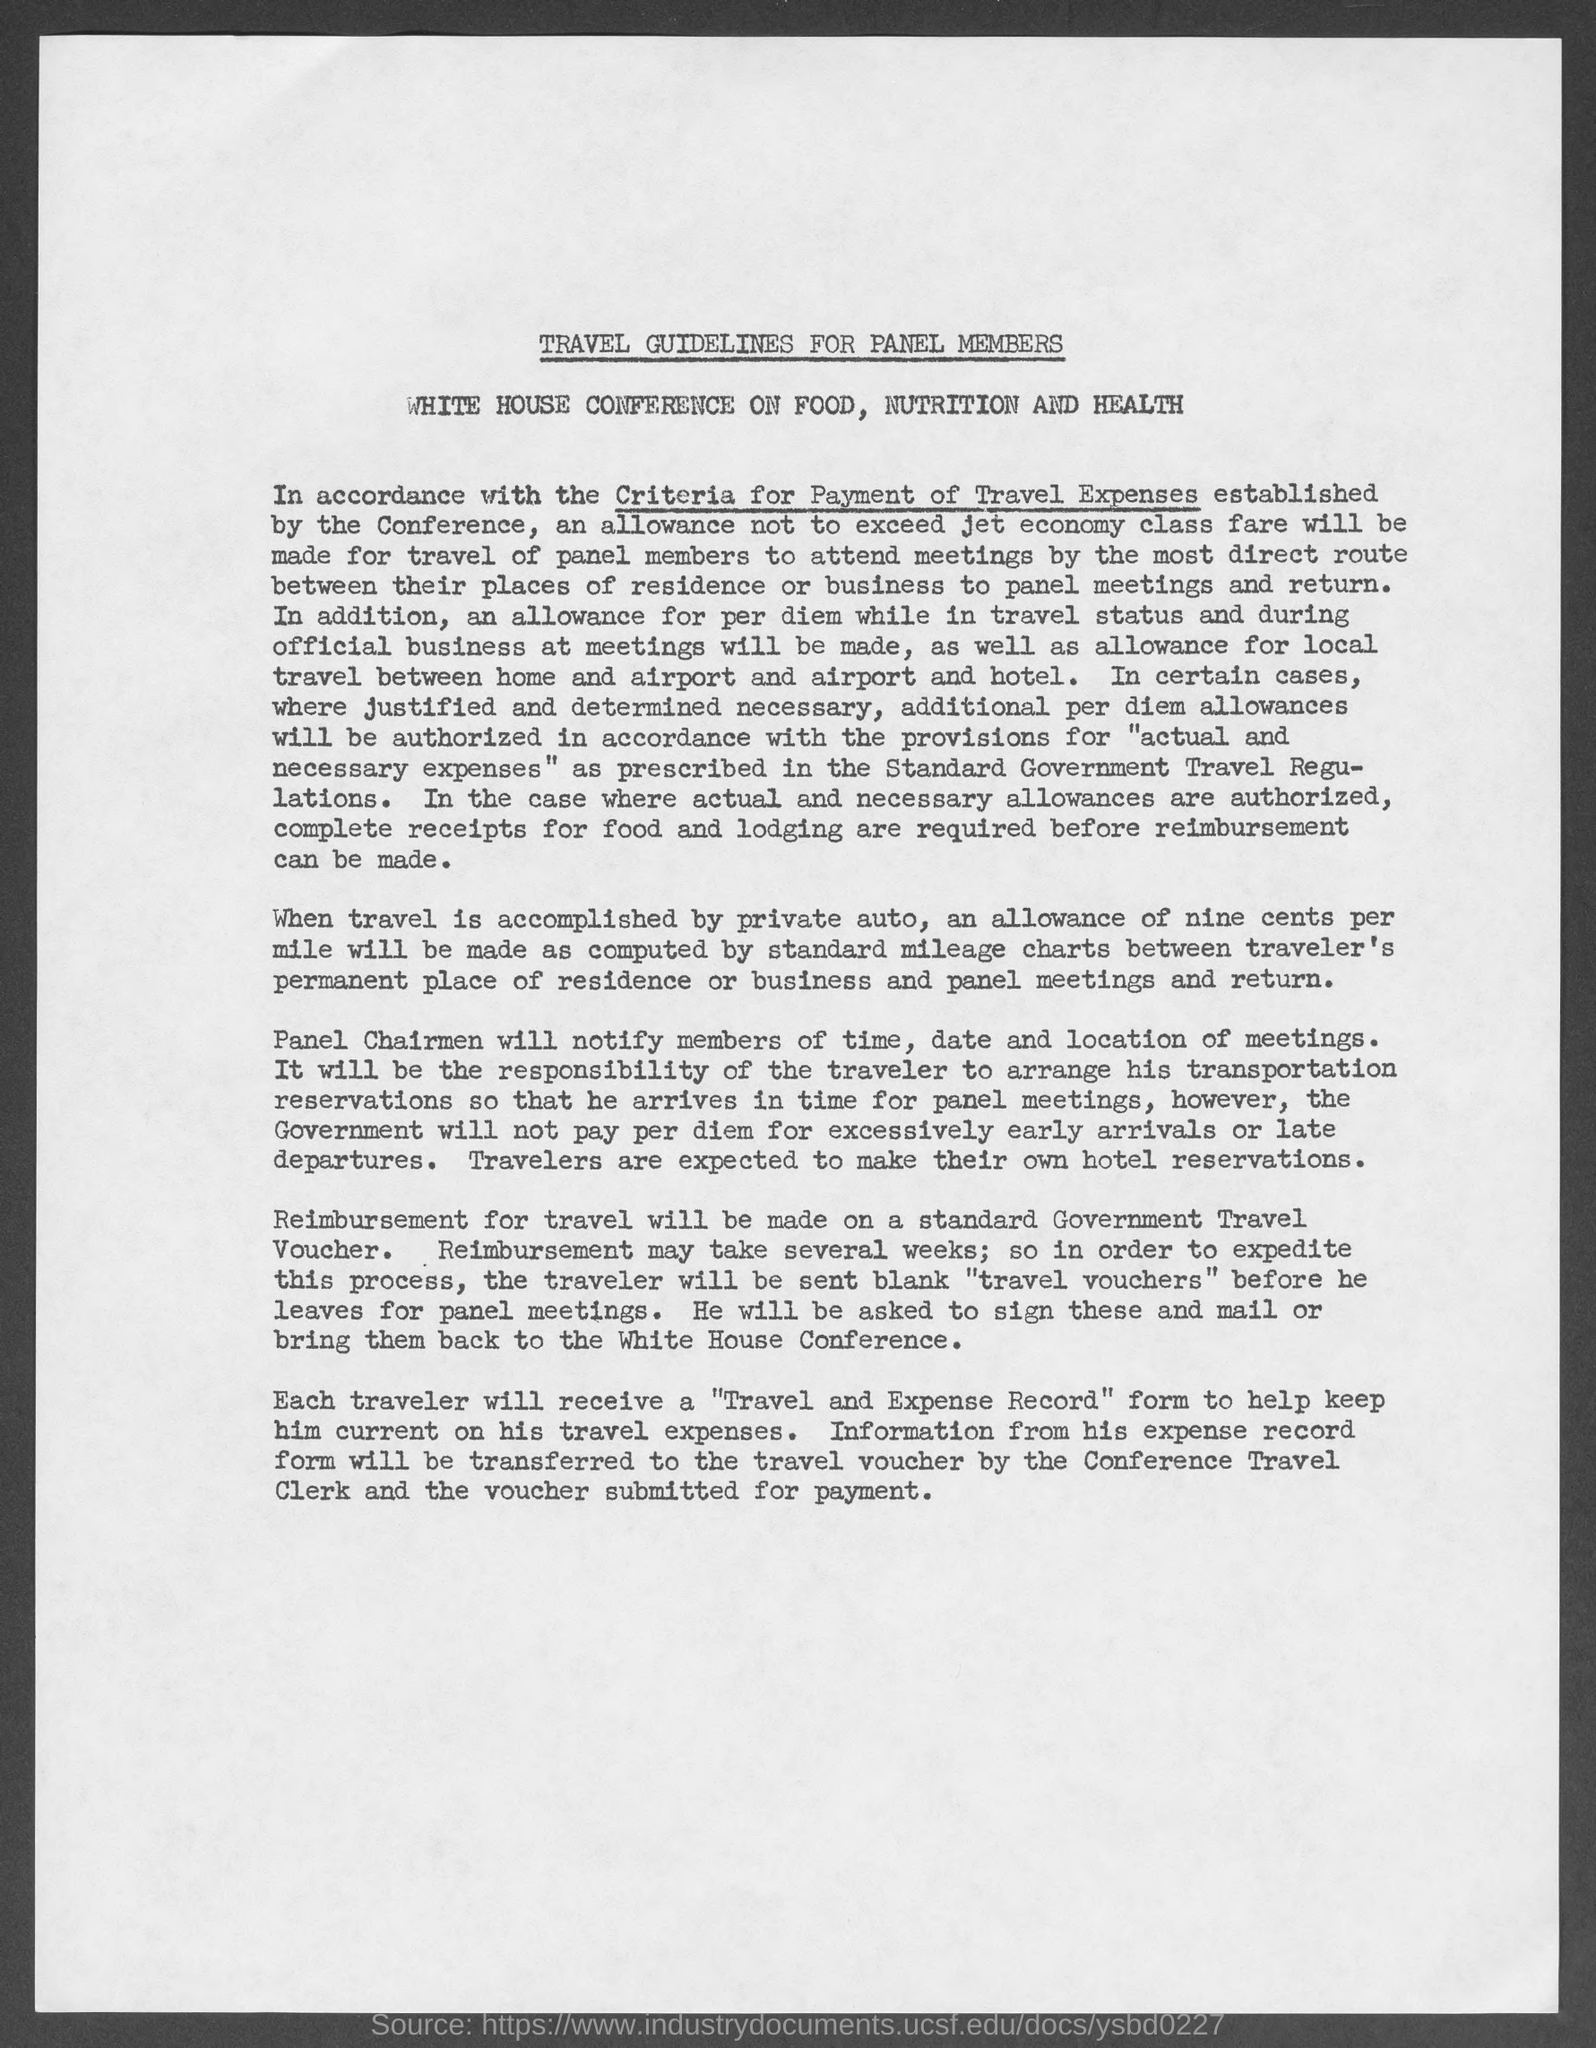What is the Title of the document?
Your answer should be compact. Travel Guidelines for panel Members. What is the allowance when travelling is accomplished by private auto?
Your answer should be compact. Nine cents per mile. Who will notify the members of time, date and location of meetings?
Your answer should be compact. Panel Chairmen. How will the reimbursement for travel be made on?
Provide a succinct answer. On standard government travel voucher. 